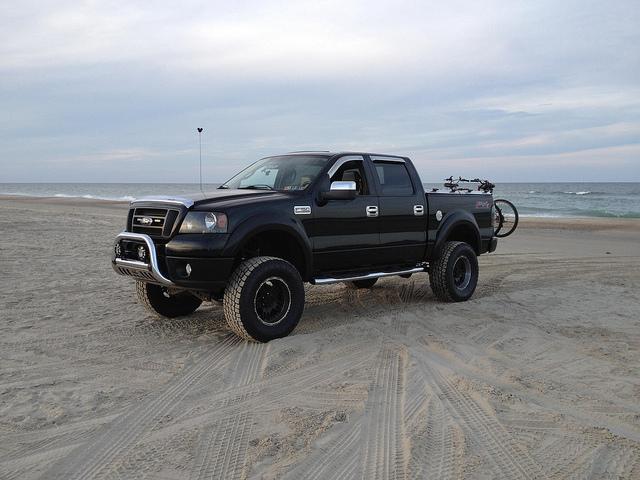Do you see a bike?
Be succinct. Yes. How many doors does the truck have?
Concise answer only. 4. Where is the truck located?
Give a very brief answer. Beach. 